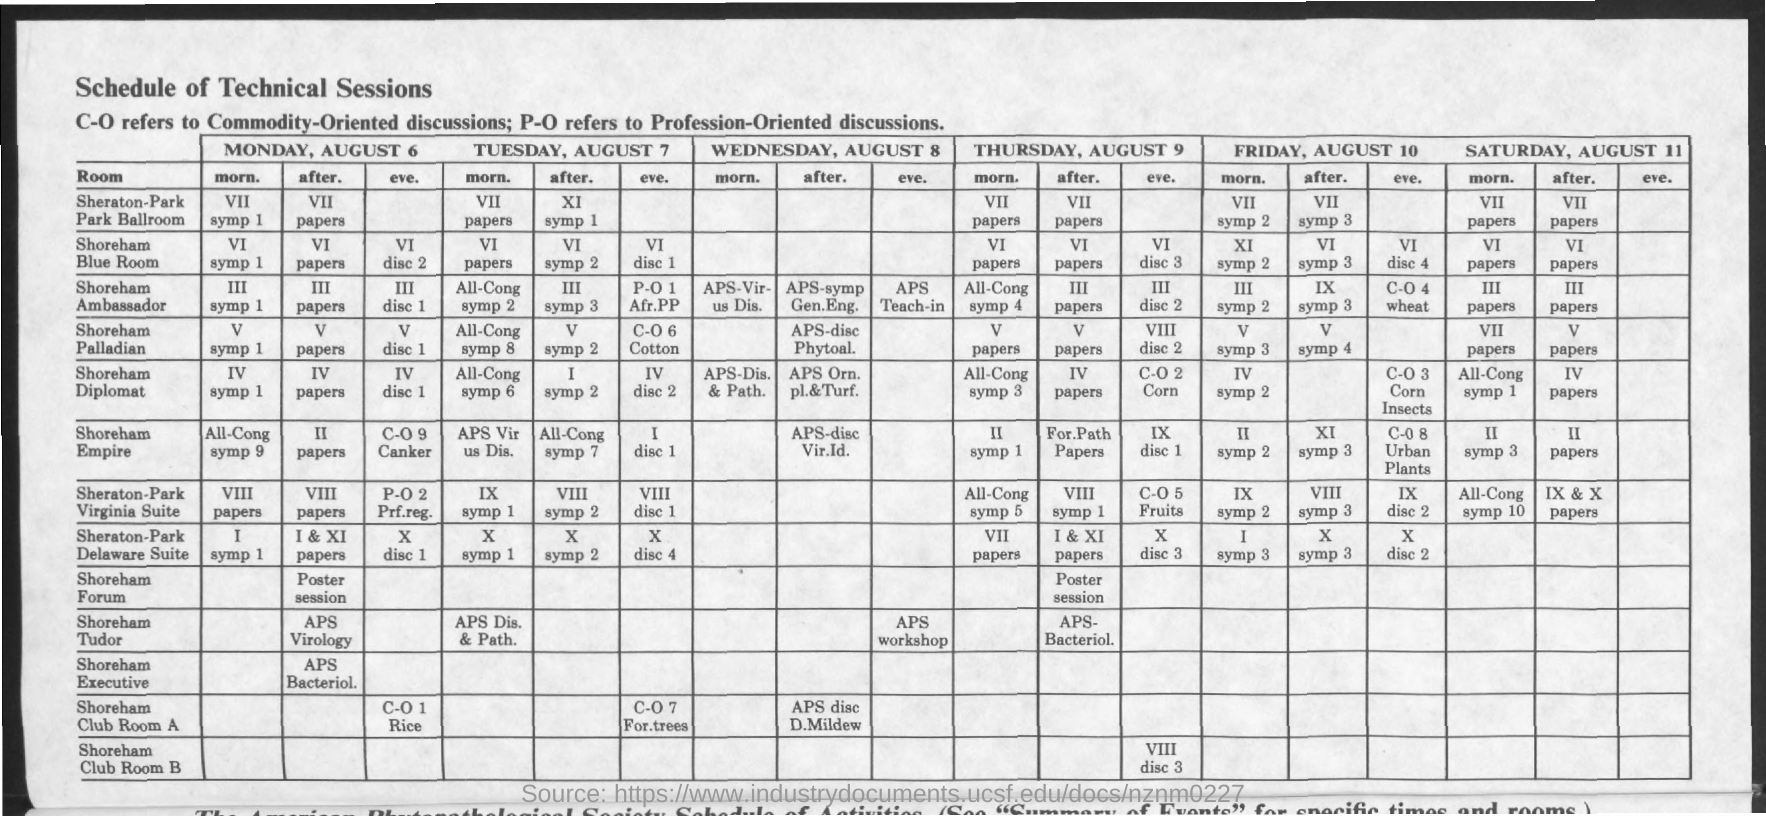What is the title of the document?
Offer a terse response. Schedule of technical sessions. What is the full form of P-O?
Give a very brief answer. Profession-Oriented. What is the full form of C-O?
Give a very brief answer. Commodity-Oriented. 